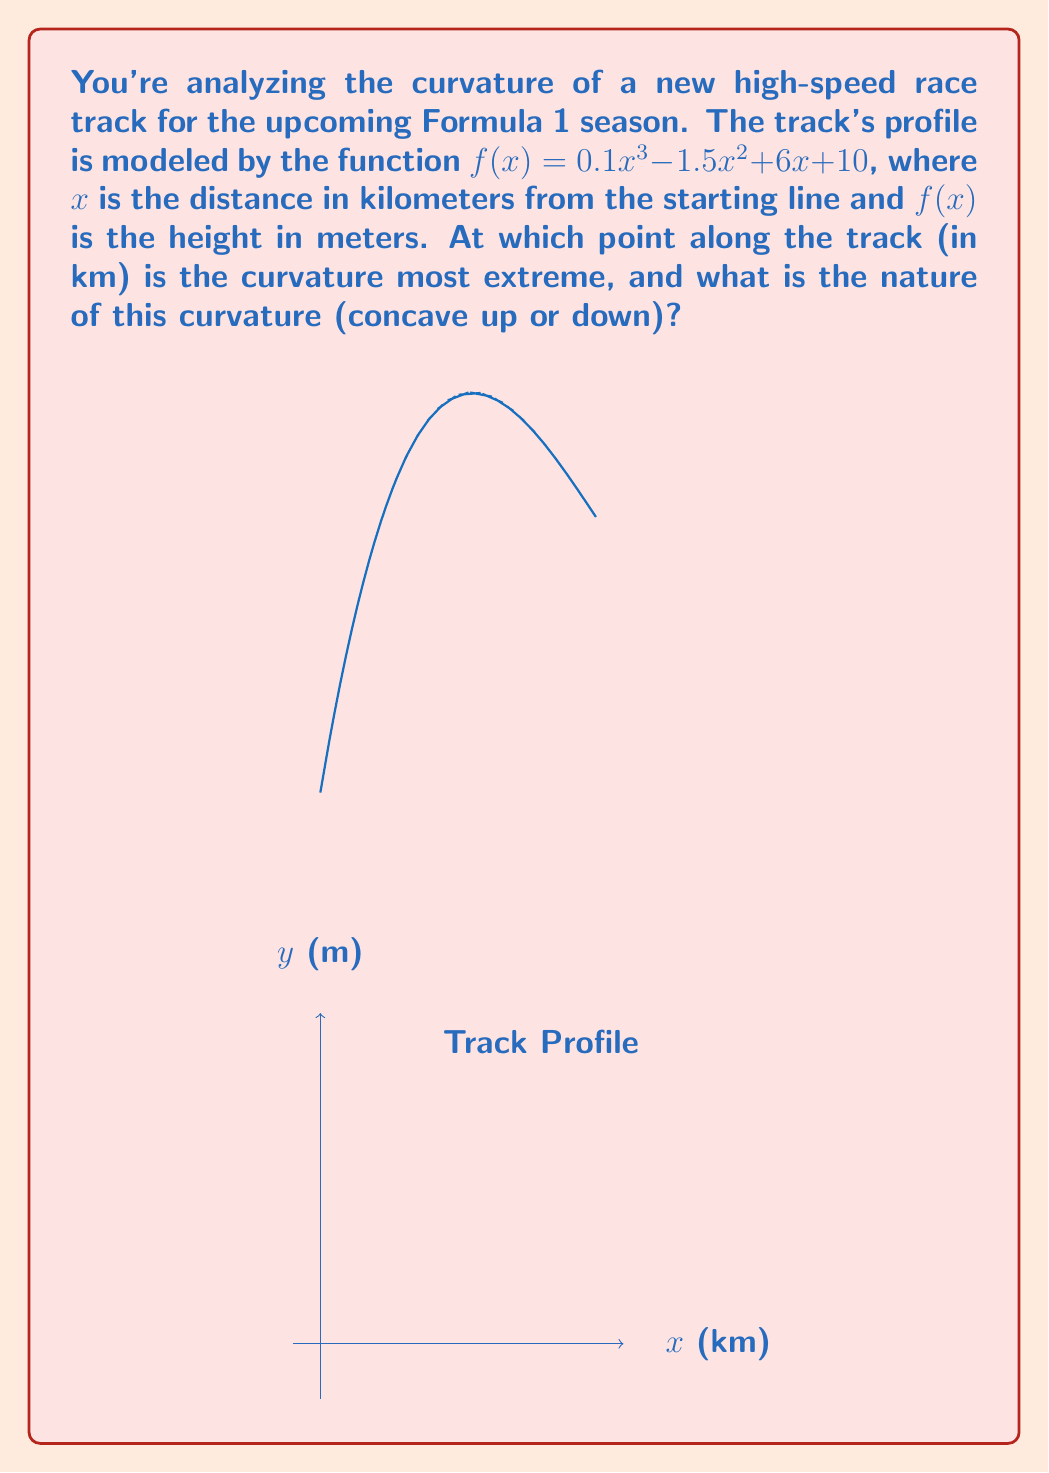Show me your answer to this math problem. To find the point of most extreme curvature, we need to analyze the second derivative of the function.

Step 1: Find the first derivative.
$$f'(x) = 0.3x^2 - 3x + 6$$

Step 2: Find the second derivative.
$$f''(x) = 0.6x - 3$$

Step 3: The point of most extreme curvature occurs where $|f''(x)|$ is at its maximum. Since $f''(x)$ is linear, its absolute maximum will occur at one of the endpoints or where it changes sign.

Step 4: Find where $f''(x) = 0$:
$$0.6x - 3 = 0$$
$$x = 5$$

Step 5: Since the race track starts at $x = 0$ and $x = 5$ is within a reasonable track length, the most extreme curvature will occur at either $x = 0$ or $x = 5$.

Step 6: Evaluate $|f''(x)|$ at these points:
At $x = 0$: $|f''(0)| = |-3| = 3$
At $x = 5$: $|f''(5)| = |0.6(5) - 3| = 0$

Step 7: The larger absolute value occurs at $x = 0$, so this is where the curvature is most extreme.

Step 8: Determine the nature of the curvature by evaluating $f''(0)$:
$f''(0) = -3 < 0$, so the curve is concave down at this point.
Answer: Most extreme curvature at $x = 0$ km, concave down. 